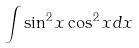<formula> <loc_0><loc_0><loc_500><loc_500>\int \sin ^ { 2 } x \cos ^ { 2 } x d x</formula> 